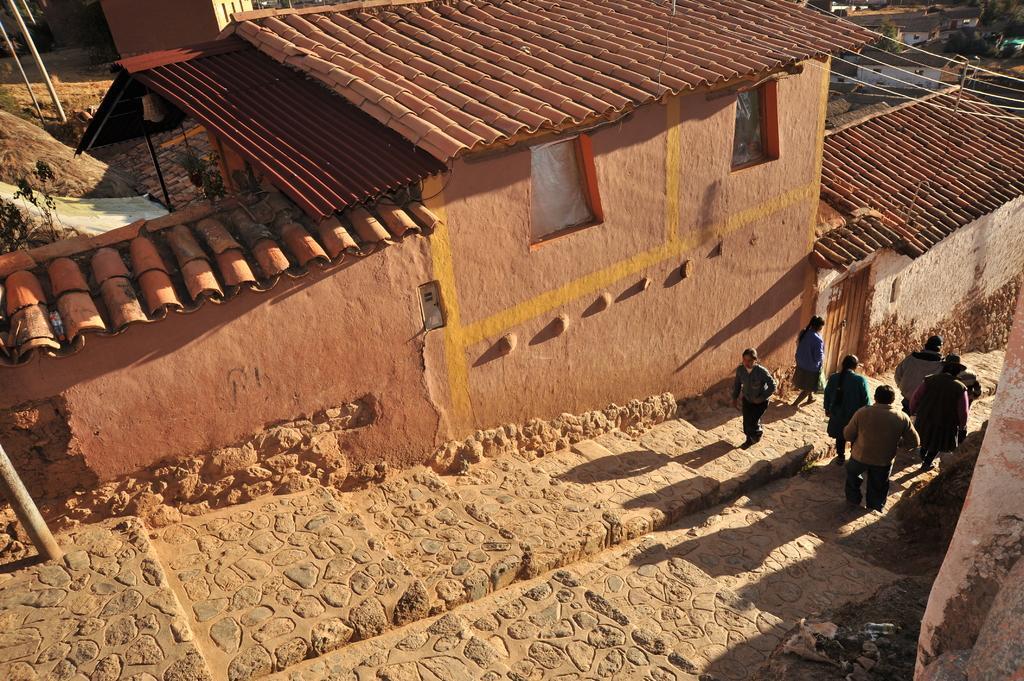Describe this image in one or two sentences. In the center of the image, we can see people on the stairs. In the background, there are houses and we can see poles along with wires and there are trees and plants. 